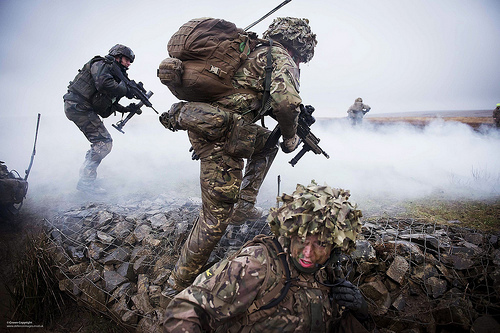<image>
Can you confirm if the backpack is on the wall? No. The backpack is not positioned on the wall. They may be near each other, but the backpack is not supported by or resting on top of the wall. Where is the soldier in relation to the soldier? Is it behind the soldier? Yes. From this viewpoint, the soldier is positioned behind the soldier, with the soldier partially or fully occluding the soldier. 